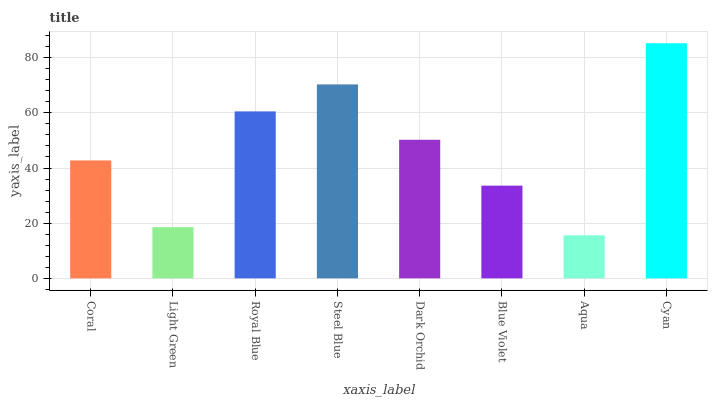Is Aqua the minimum?
Answer yes or no. Yes. Is Cyan the maximum?
Answer yes or no. Yes. Is Light Green the minimum?
Answer yes or no. No. Is Light Green the maximum?
Answer yes or no. No. Is Coral greater than Light Green?
Answer yes or no. Yes. Is Light Green less than Coral?
Answer yes or no. Yes. Is Light Green greater than Coral?
Answer yes or no. No. Is Coral less than Light Green?
Answer yes or no. No. Is Dark Orchid the high median?
Answer yes or no. Yes. Is Coral the low median?
Answer yes or no. Yes. Is Royal Blue the high median?
Answer yes or no. No. Is Cyan the low median?
Answer yes or no. No. 